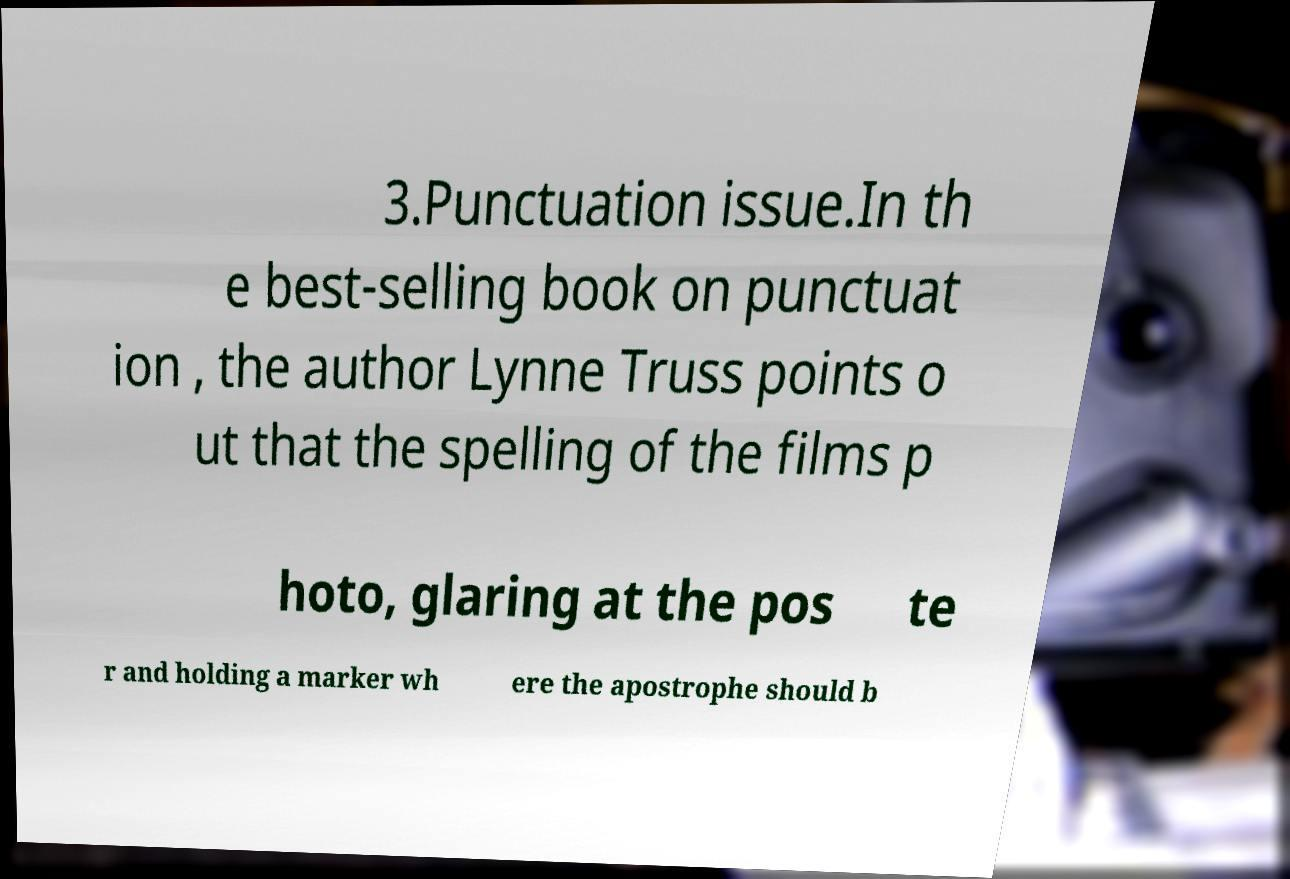Please identify and transcribe the text found in this image. 3.Punctuation issue.In th e best-selling book on punctuat ion , the author Lynne Truss points o ut that the spelling of the films p hoto, glaring at the pos te r and holding a marker wh ere the apostrophe should b 